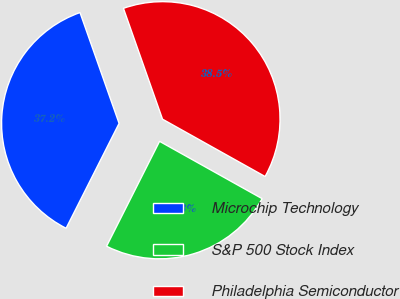Convert chart. <chart><loc_0><loc_0><loc_500><loc_500><pie_chart><fcel>Microchip Technology<fcel>S&P 500 Stock Index<fcel>Philadelphia Semiconductor<nl><fcel>37.16%<fcel>24.33%<fcel>38.51%<nl></chart> 